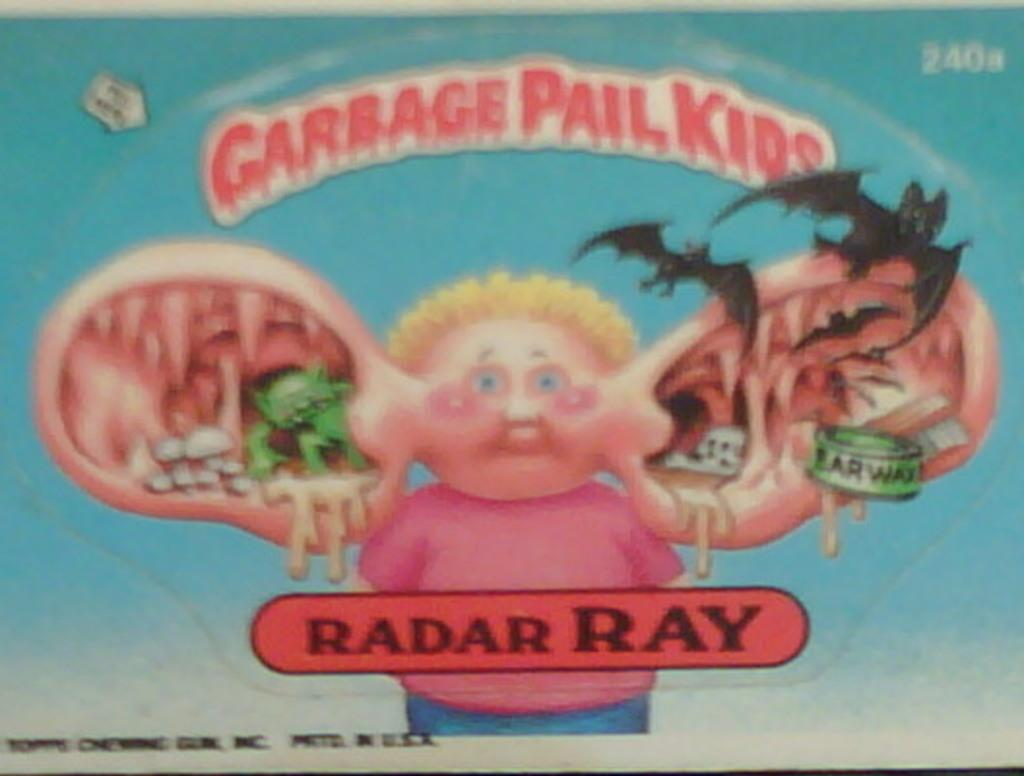<image>
Render a clear and concise summary of the photo. garbage pail kids by radar ray book with a kids 